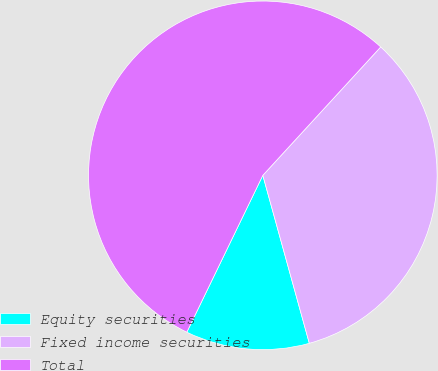Convert chart to OTSL. <chart><loc_0><loc_0><loc_500><loc_500><pie_chart><fcel>Equity securities<fcel>Fixed income securities<fcel>Total<nl><fcel>11.48%<fcel>33.88%<fcel>54.64%<nl></chart> 